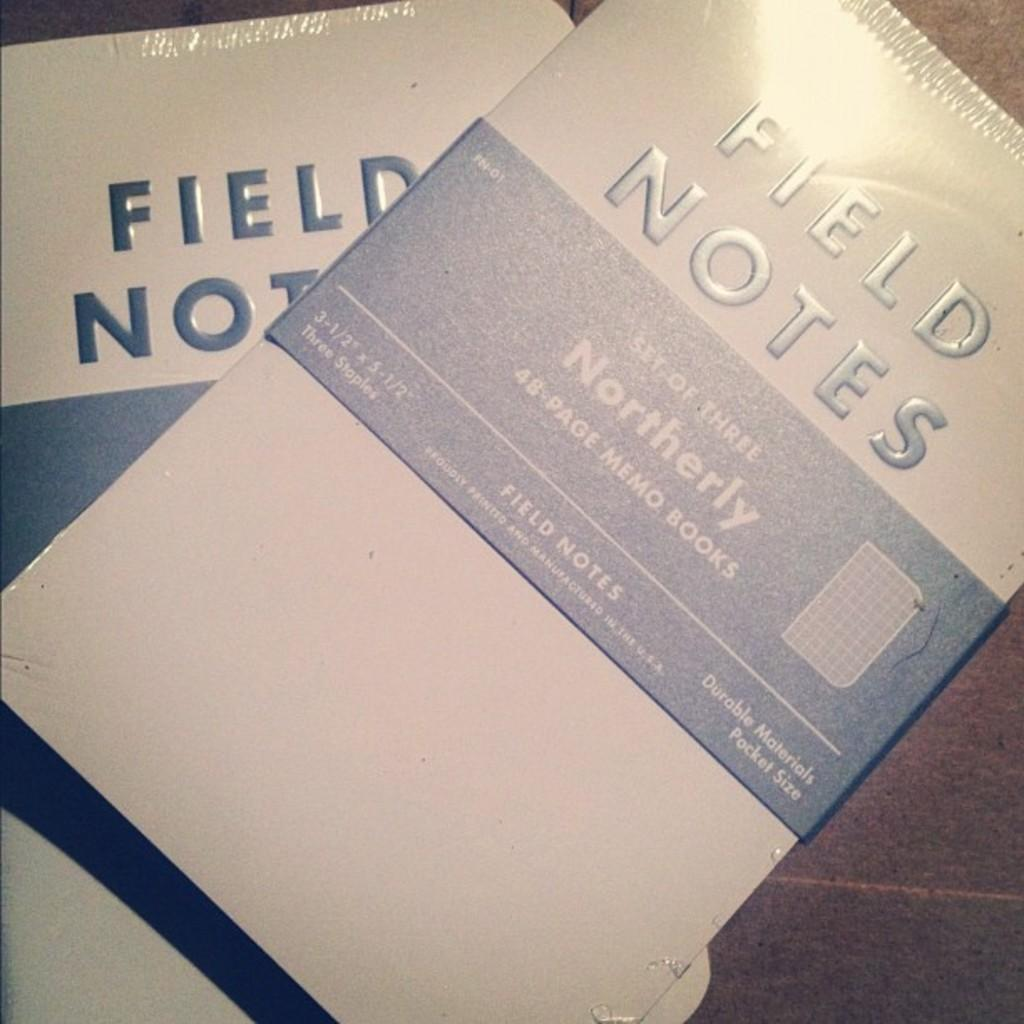Provide a one-sentence caption for the provided image. A white and blue booklet that is titled, "Field Notes.". 